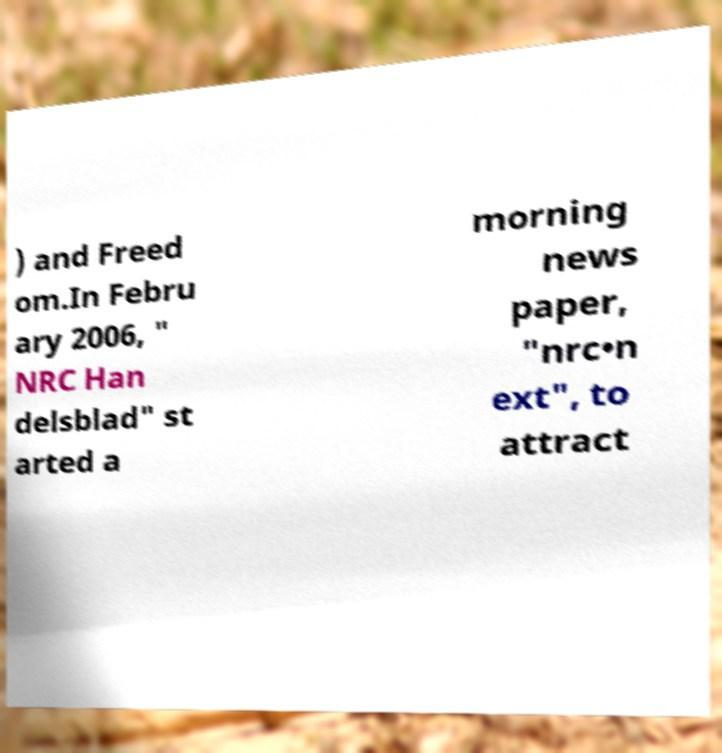Can you read and provide the text displayed in the image?This photo seems to have some interesting text. Can you extract and type it out for me? ) and Freed om.In Febru ary 2006, " NRC Han delsblad" st arted a morning news paper, "nrc•n ext", to attract 